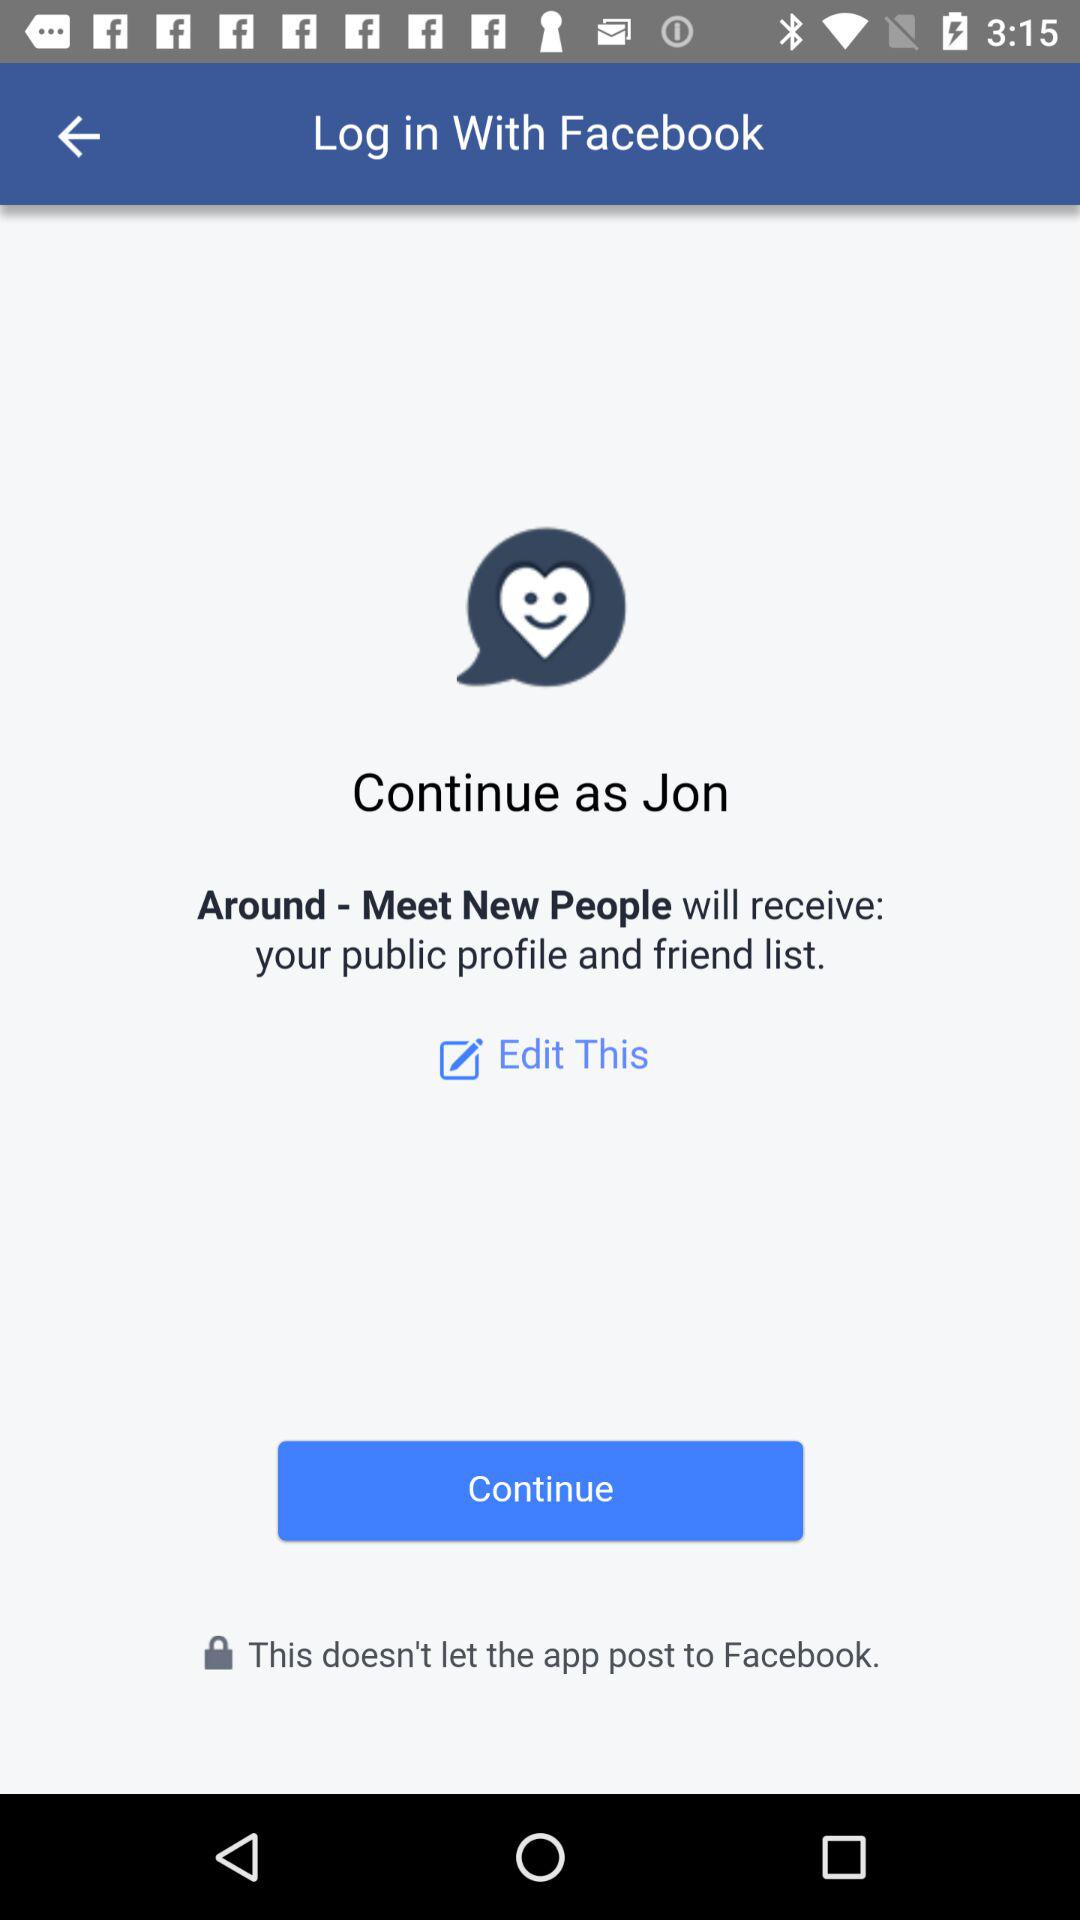What is Jon's surname?
When the provided information is insufficient, respond with <no answer>. <no answer> 